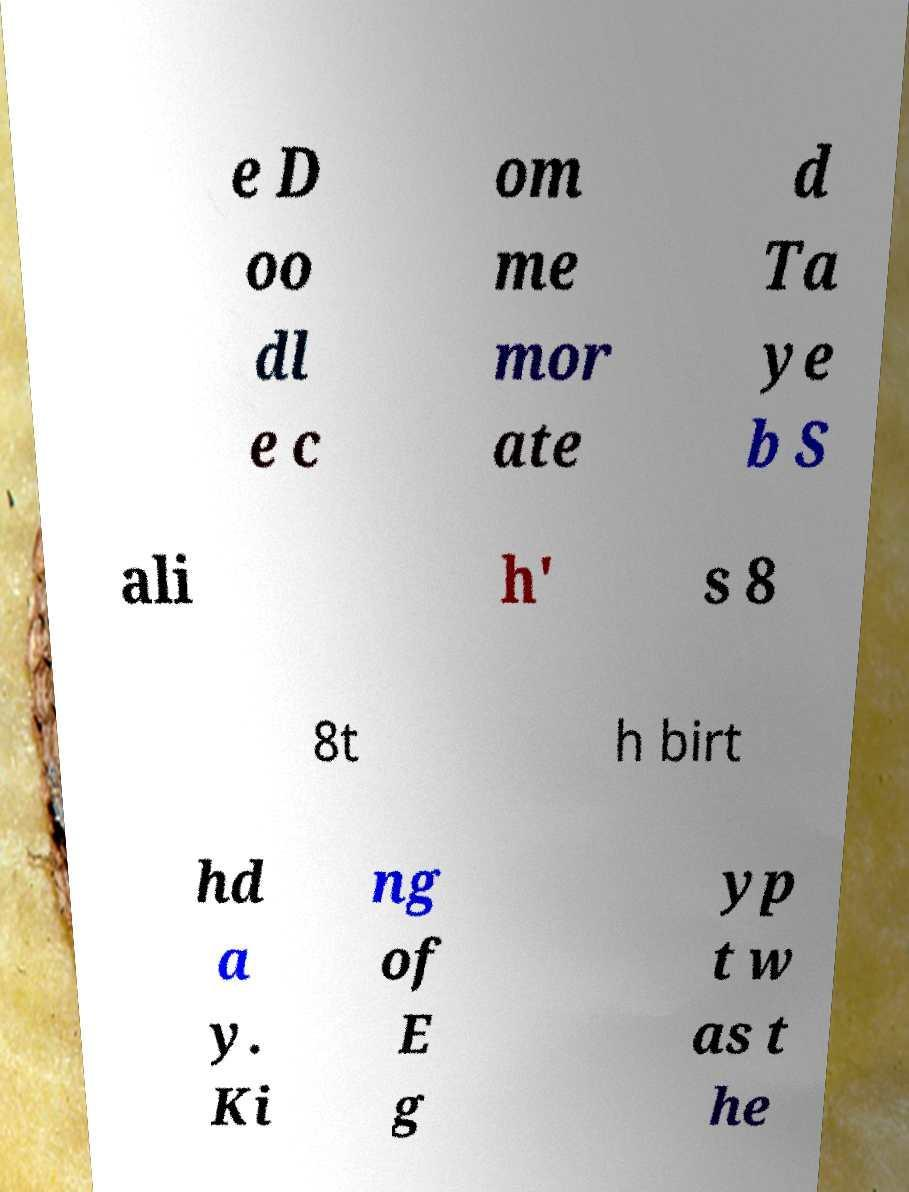There's text embedded in this image that I need extracted. Can you transcribe it verbatim? e D oo dl e c om me mor ate d Ta ye b S ali h' s 8 8t h birt hd a y. Ki ng of E g yp t w as t he 